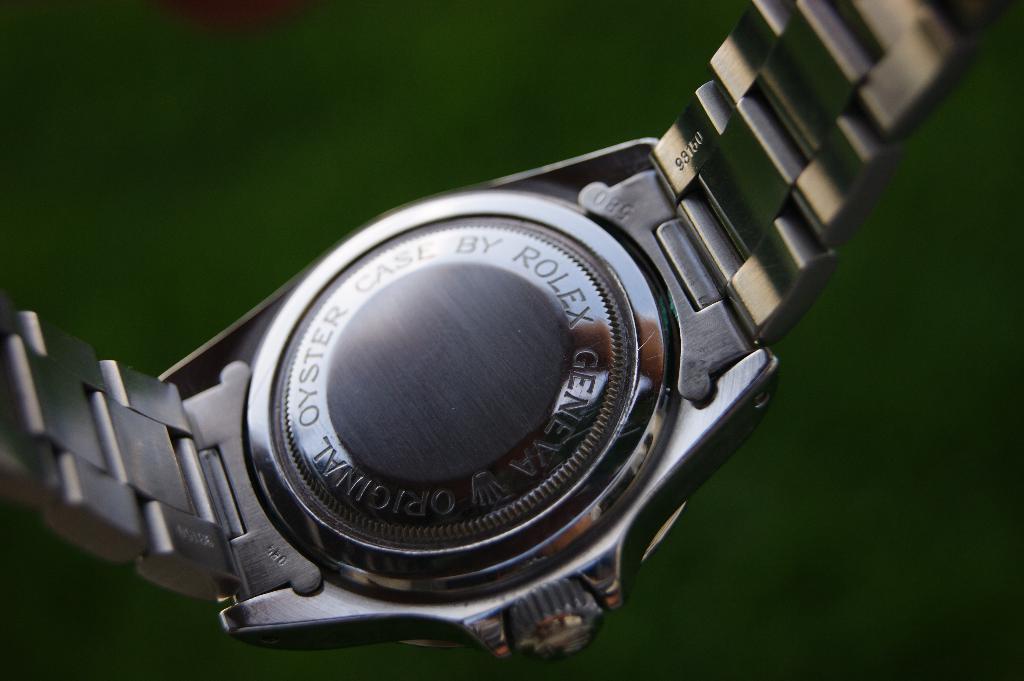Can you describe this image briefly? In this image I can see a watch and the background is green in color. 